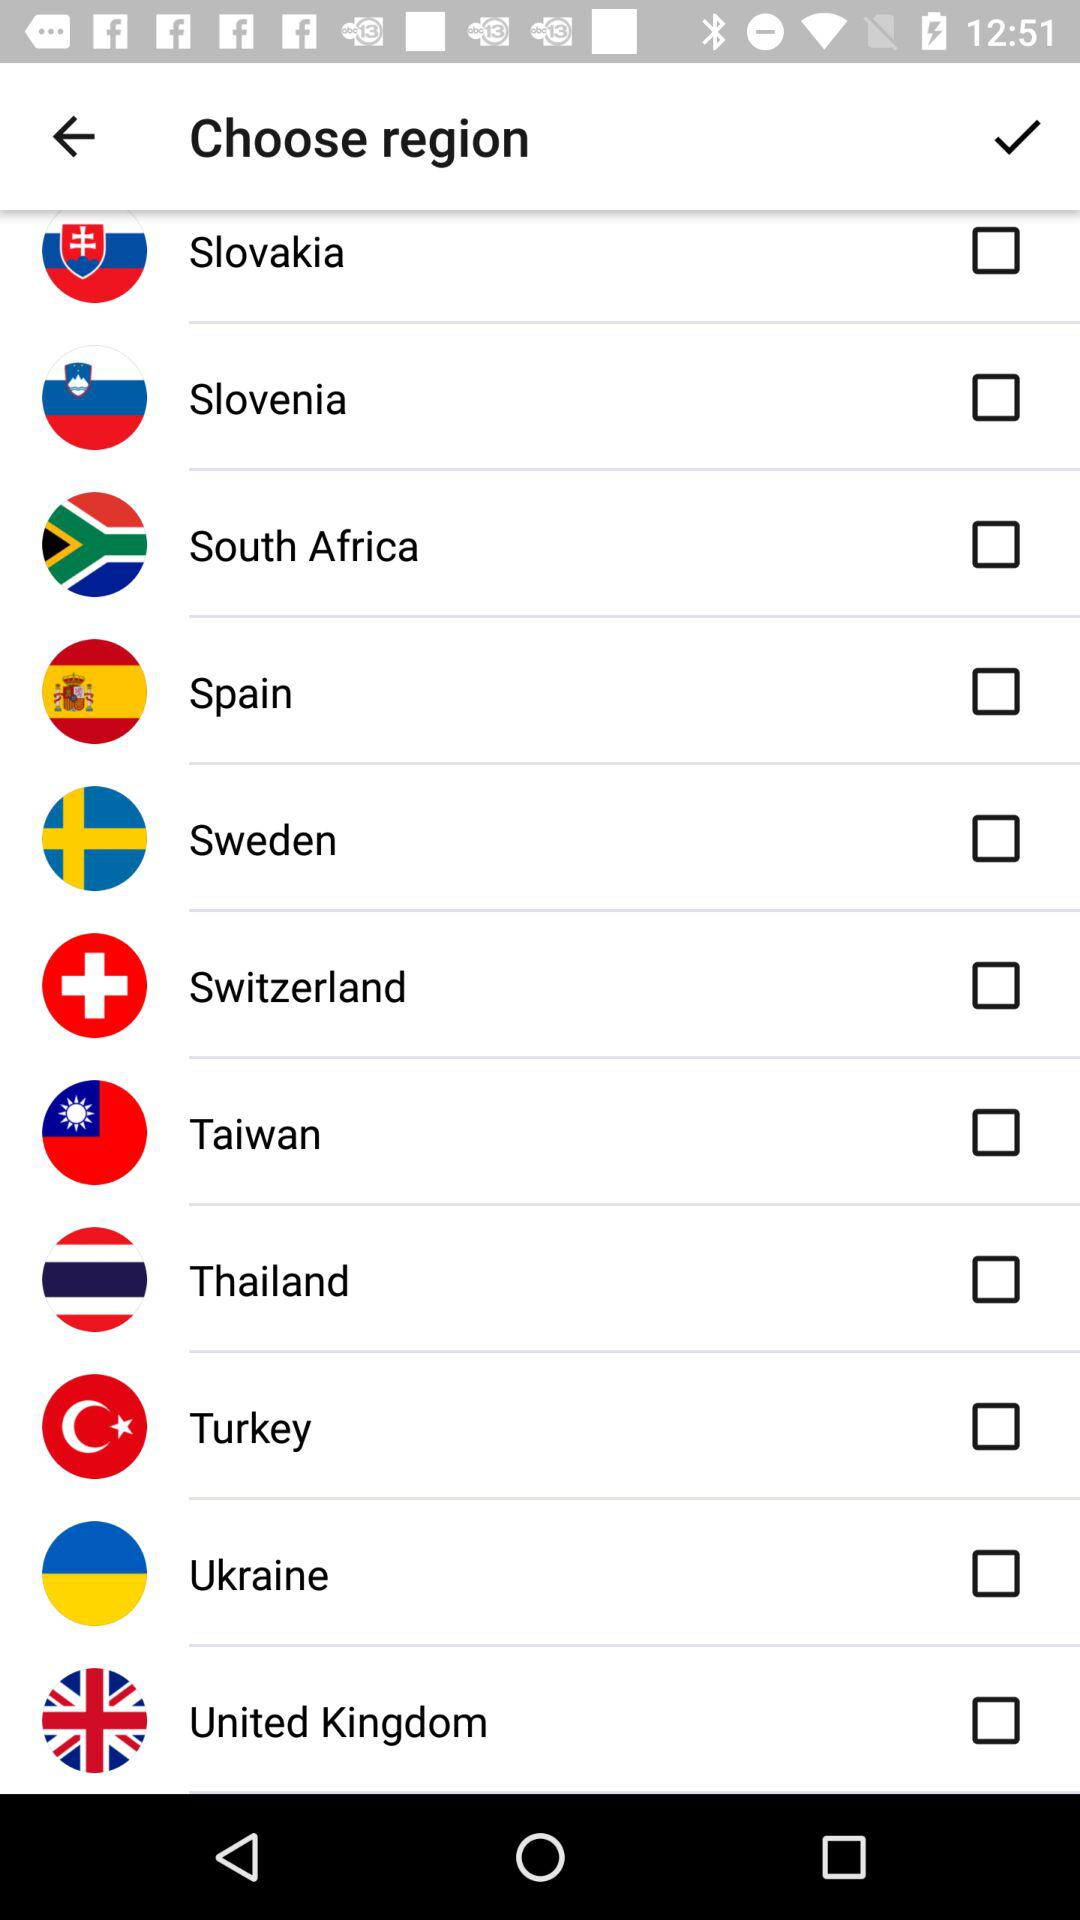What are the different regions shown on the screen? The different shown regions are "Slovakia", "Slovenia", "South Africa", "Spain", "Sweden", "Switzerland", "Taiwan", "Thailand", "Turkey", "Ukraine" and "United Kingdom". 